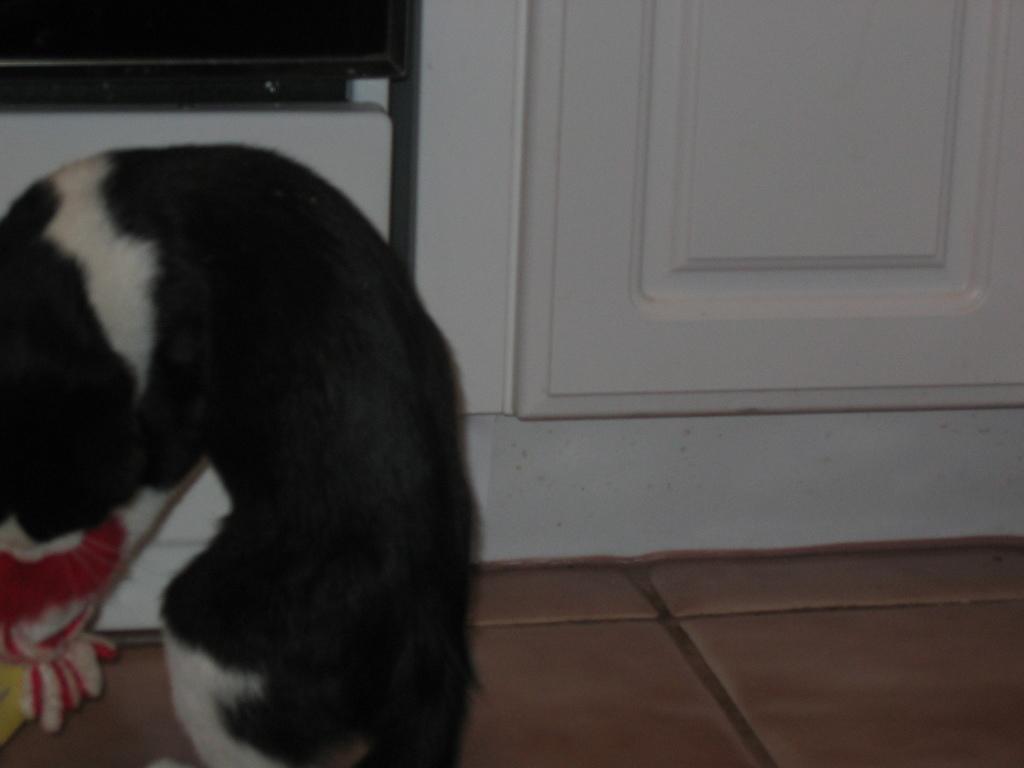Please provide a concise description of this image. In the foreground of this image, there is a dog on the left side on the floor. In the background, there is a wall and at the top, there is the screen. 